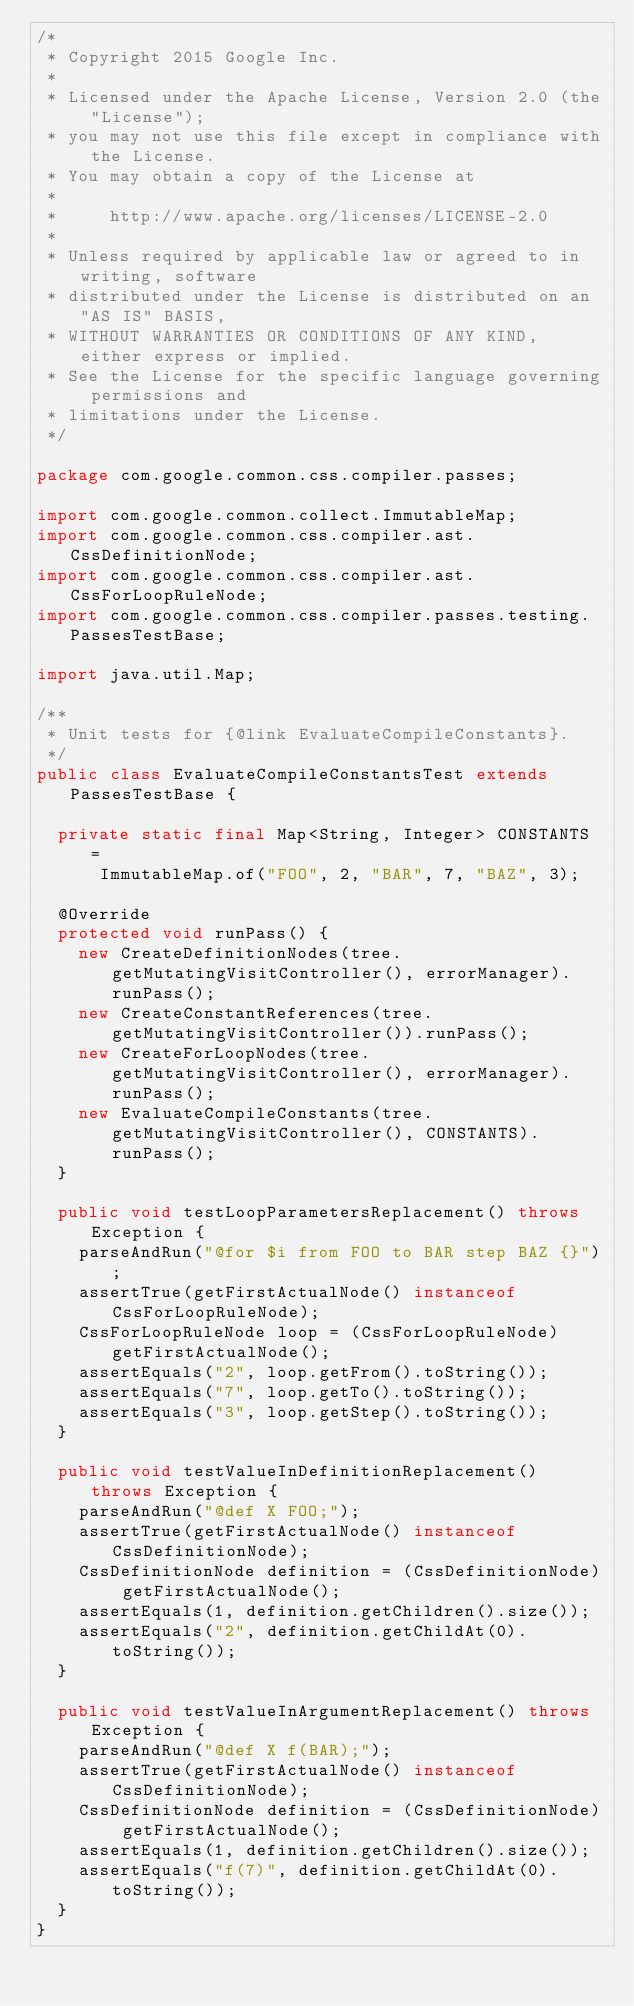Convert code to text. <code><loc_0><loc_0><loc_500><loc_500><_Java_>/*
 * Copyright 2015 Google Inc.
 *
 * Licensed under the Apache License, Version 2.0 (the "License");
 * you may not use this file except in compliance with the License.
 * You may obtain a copy of the License at
 *
 *     http://www.apache.org/licenses/LICENSE-2.0
 *
 * Unless required by applicable law or agreed to in writing, software
 * distributed under the License is distributed on an "AS IS" BASIS,
 * WITHOUT WARRANTIES OR CONDITIONS OF ANY KIND, either express or implied.
 * See the License for the specific language governing permissions and
 * limitations under the License.
 */

package com.google.common.css.compiler.passes;

import com.google.common.collect.ImmutableMap;
import com.google.common.css.compiler.ast.CssDefinitionNode;
import com.google.common.css.compiler.ast.CssForLoopRuleNode;
import com.google.common.css.compiler.passes.testing.PassesTestBase;

import java.util.Map;

/**
 * Unit tests for {@link EvaluateCompileConstants}.
 */
public class EvaluateCompileConstantsTest extends PassesTestBase {

  private static final Map<String, Integer> CONSTANTS =
      ImmutableMap.of("FOO", 2, "BAR", 7, "BAZ", 3);

  @Override
  protected void runPass() {
    new CreateDefinitionNodes(tree.getMutatingVisitController(), errorManager).runPass();
    new CreateConstantReferences(tree.getMutatingVisitController()).runPass();
    new CreateForLoopNodes(tree.getMutatingVisitController(), errorManager).runPass();
    new EvaluateCompileConstants(tree.getMutatingVisitController(), CONSTANTS).runPass();
  }

  public void testLoopParametersReplacement() throws Exception {
    parseAndRun("@for $i from FOO to BAR step BAZ {}");
    assertTrue(getFirstActualNode() instanceof CssForLoopRuleNode);
    CssForLoopRuleNode loop = (CssForLoopRuleNode) getFirstActualNode();
    assertEquals("2", loop.getFrom().toString());
    assertEquals("7", loop.getTo().toString());
    assertEquals("3", loop.getStep().toString());
  }

  public void testValueInDefinitionReplacement() throws Exception {
    parseAndRun("@def X FOO;");
    assertTrue(getFirstActualNode() instanceof CssDefinitionNode);
    CssDefinitionNode definition = (CssDefinitionNode) getFirstActualNode();
    assertEquals(1, definition.getChildren().size());
    assertEquals("2", definition.getChildAt(0).toString());
  }

  public void testValueInArgumentReplacement() throws Exception {
    parseAndRun("@def X f(BAR);");
    assertTrue(getFirstActualNode() instanceof CssDefinitionNode);
    CssDefinitionNode definition = (CssDefinitionNode) getFirstActualNode();
    assertEquals(1, definition.getChildren().size());
    assertEquals("f(7)", definition.getChildAt(0).toString());
  }
}
</code> 